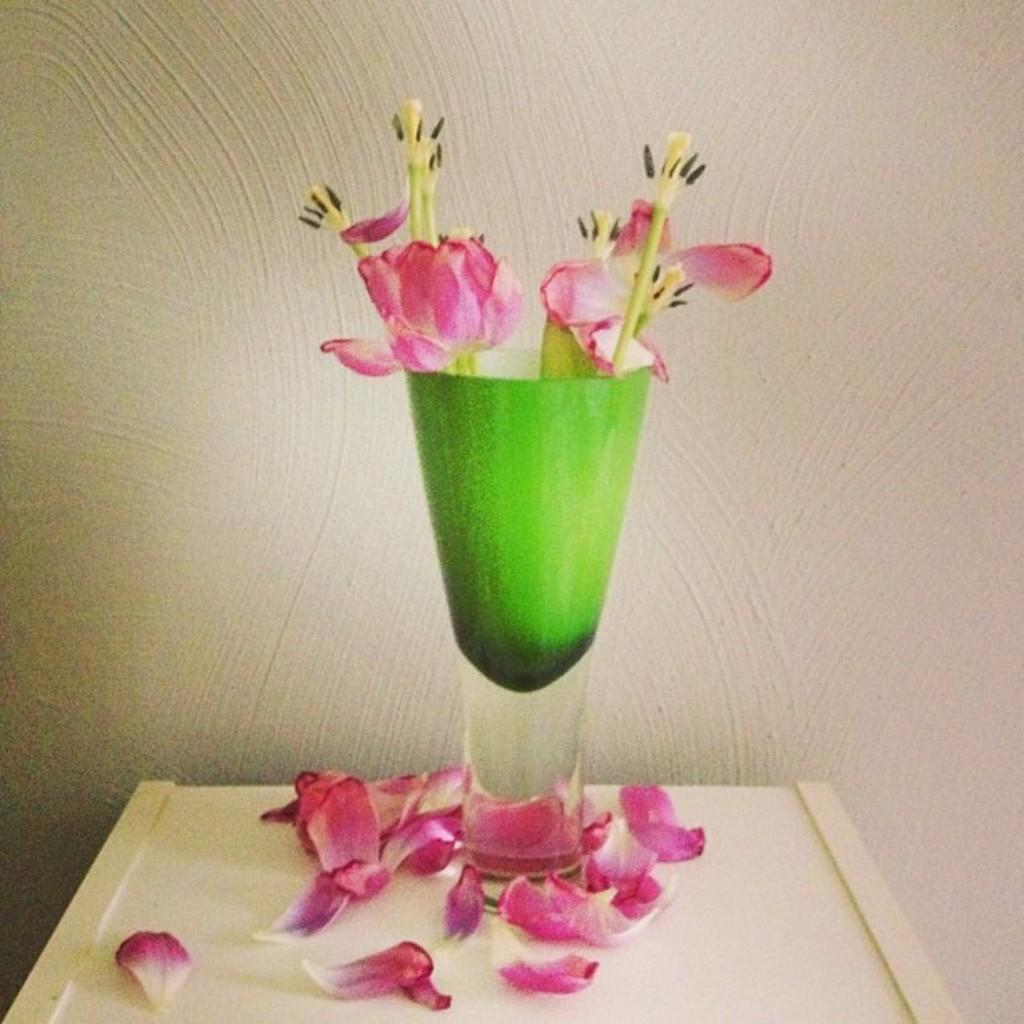What is in the vase that is visible in the image? There are flowers in a vase in the image. Where is the vase located in the image? The vase is placed on a table. What can be seen around the vase in the image? There are petals beside the vase. What is visible in the background of the image? There is a wall visible in the background of the image. What type of ink can be seen dripping from the ornament in the image? There is no ornament or ink present in the image. The image only features flowers in a vase, a table, petals, and a wall in the background. 